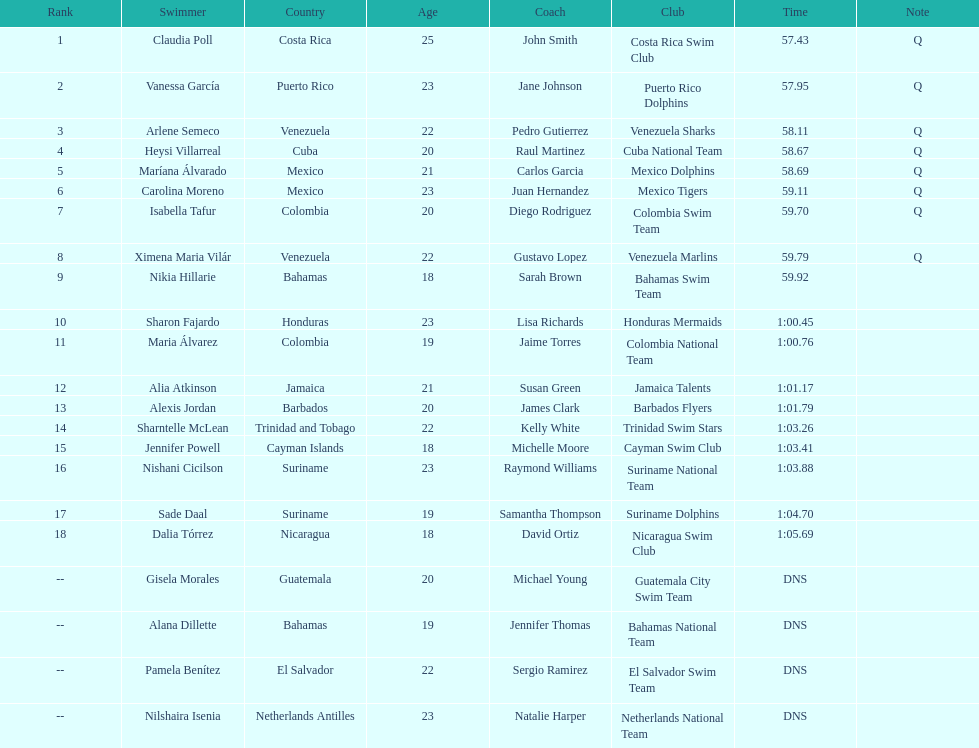What was claudia roll's time? 57.43. 